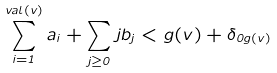Convert formula to latex. <formula><loc_0><loc_0><loc_500><loc_500>\sum _ { i = 1 } ^ { v a l ( v ) } a _ { i } + \sum _ { j \geq 0 } j b _ { j } < g ( v ) + \delta _ { 0 g ( v ) }</formula> 